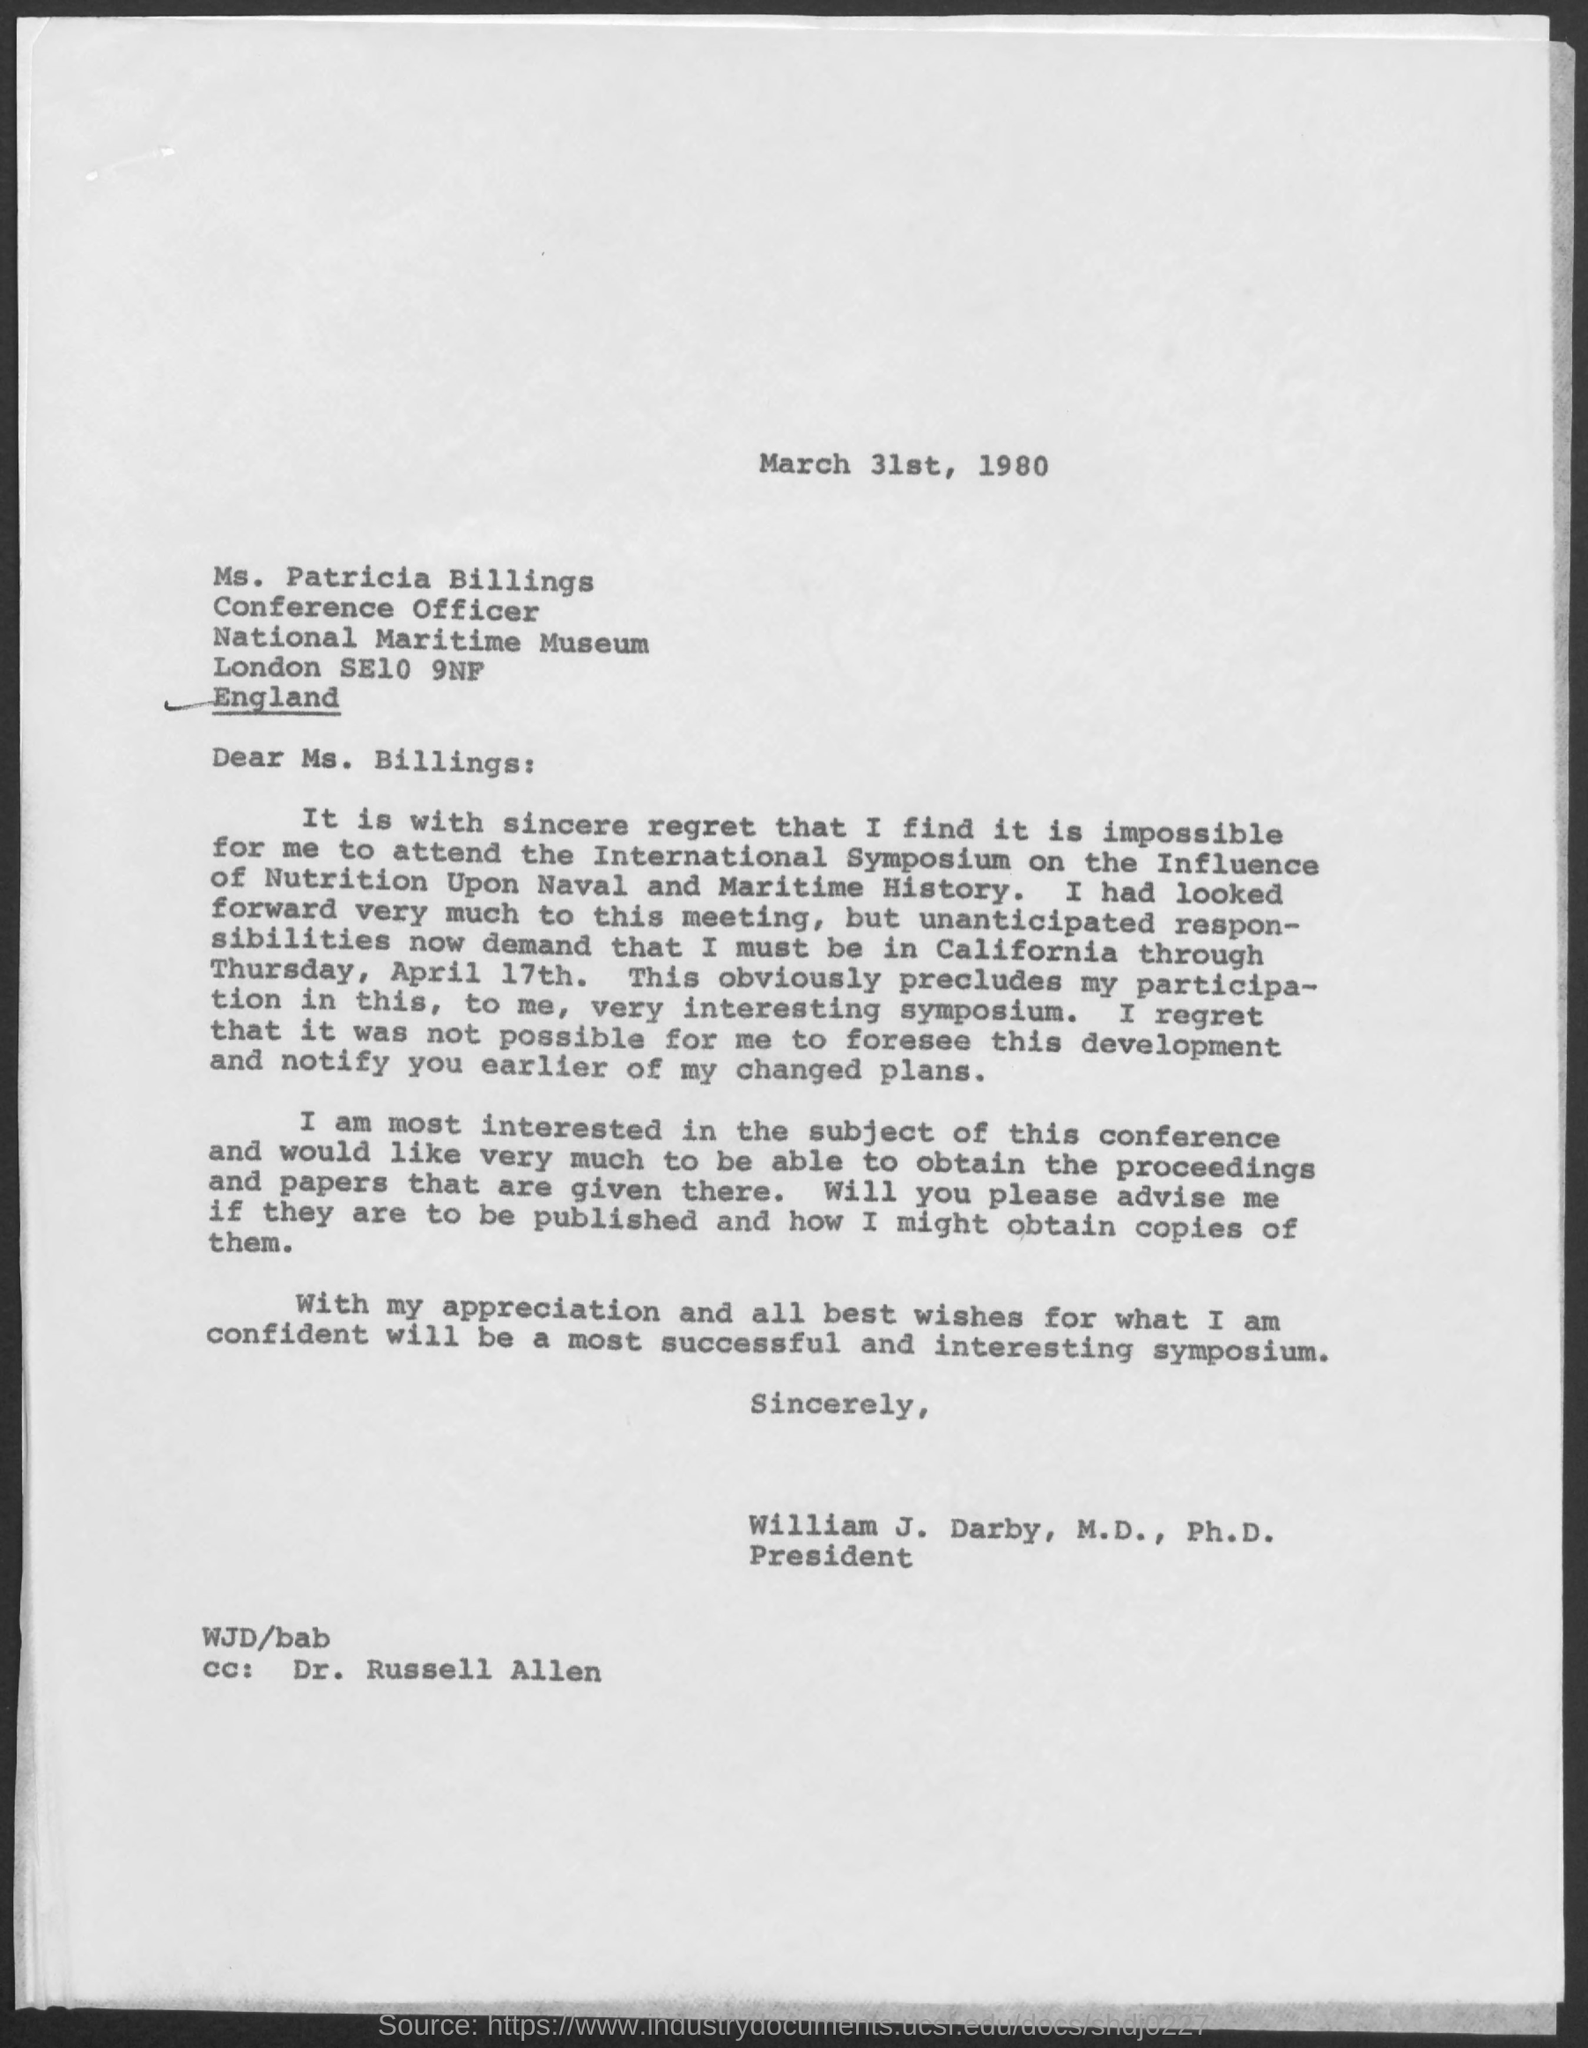Outline some significant characteristics in this image. The National Maritime Museum is the name of the museum mentioned in the given letter. Ms. Patricia Billings is referred to as "conference officer" in the given letter. The date mentioned in the given letter is March 31st, 1980. The letter was written to Patricia Billings. William J. Darby holds the designation of president. 